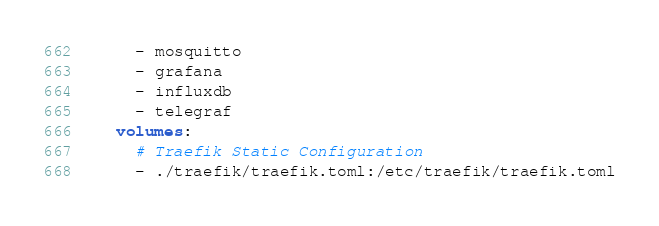<code> <loc_0><loc_0><loc_500><loc_500><_YAML_>      - mosquitto
      - grafana
      - influxdb
      - telegraf
    volumes:
      # Traefik Static Configuration
      - ./traefik/traefik.toml:/etc/traefik/traefik.toml</code> 